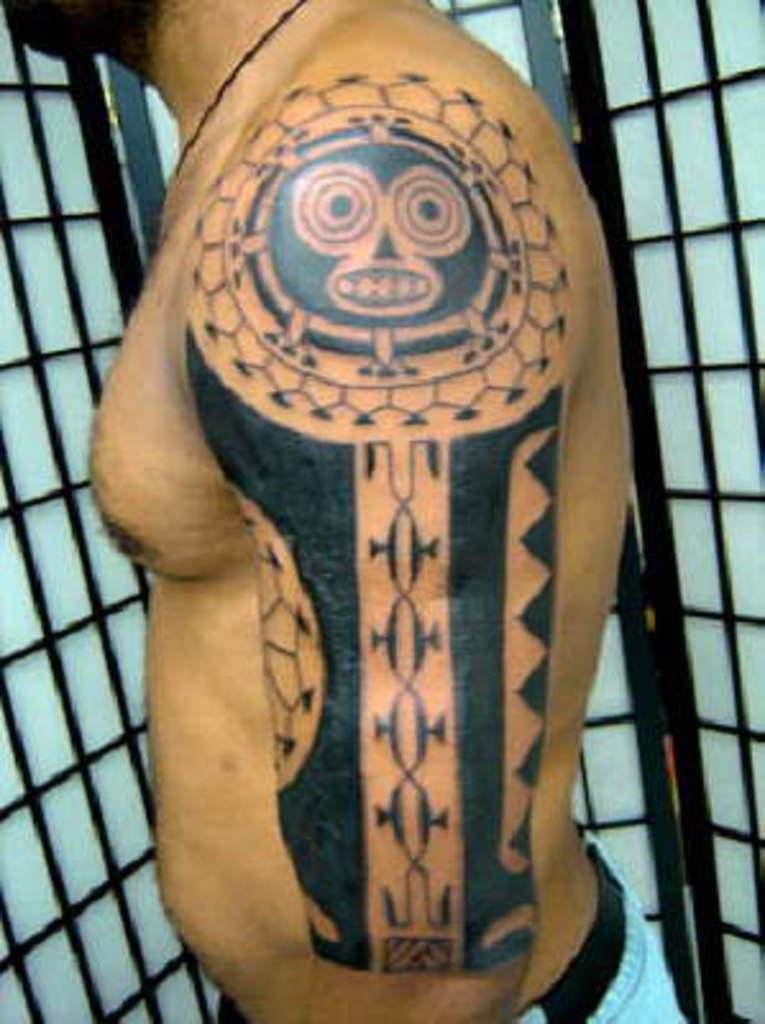What is the main subject of the image? There is a person standing in the image. Can you describe any distinguishing features of the person? The person has a tattoo on their hand. What can be seen in the background of the image? There are grilles in the background of the image. What type of poison is the person holding in the image? There is no poison present in the image; the person has a tattoo on their hand and is standing in front of grilles. 